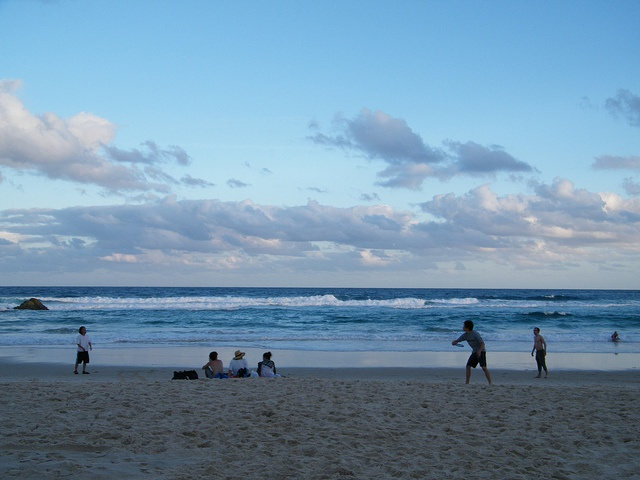Describe the objects in this image and their specific colors. I can see people in lightblue, black, blue, gray, and navy tones, people in lightblue, black, and gray tones, people in lightblue, black, navy, purple, and gray tones, people in lightblue, black, gray, and navy tones, and people in lightblue, black, navy, and gray tones in this image. 